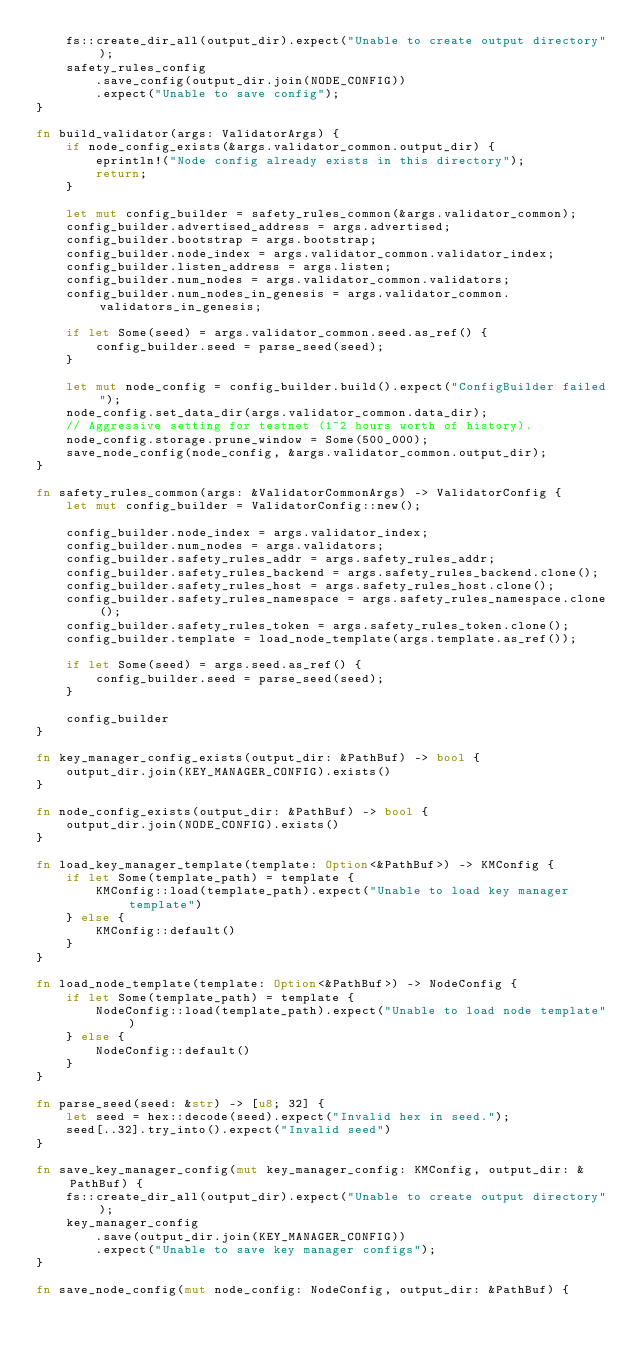Convert code to text. <code><loc_0><loc_0><loc_500><loc_500><_Rust_>    fs::create_dir_all(output_dir).expect("Unable to create output directory");
    safety_rules_config
        .save_config(output_dir.join(NODE_CONFIG))
        .expect("Unable to save config");
}

fn build_validator(args: ValidatorArgs) {
    if node_config_exists(&args.validator_common.output_dir) {
        eprintln!("Node config already exists in this directory");
        return;
    }

    let mut config_builder = safety_rules_common(&args.validator_common);
    config_builder.advertised_address = args.advertised;
    config_builder.bootstrap = args.bootstrap;
    config_builder.node_index = args.validator_common.validator_index;
    config_builder.listen_address = args.listen;
    config_builder.num_nodes = args.validator_common.validators;
    config_builder.num_nodes_in_genesis = args.validator_common.validators_in_genesis;

    if let Some(seed) = args.validator_common.seed.as_ref() {
        config_builder.seed = parse_seed(seed);
    }

    let mut node_config = config_builder.build().expect("ConfigBuilder failed");
    node_config.set_data_dir(args.validator_common.data_dir);
    // Aggressive setting for testnet (1~2 hours worth of history).
    node_config.storage.prune_window = Some(500_000);
    save_node_config(node_config, &args.validator_common.output_dir);
}

fn safety_rules_common(args: &ValidatorCommonArgs) -> ValidatorConfig {
    let mut config_builder = ValidatorConfig::new();

    config_builder.node_index = args.validator_index;
    config_builder.num_nodes = args.validators;
    config_builder.safety_rules_addr = args.safety_rules_addr;
    config_builder.safety_rules_backend = args.safety_rules_backend.clone();
    config_builder.safety_rules_host = args.safety_rules_host.clone();
    config_builder.safety_rules_namespace = args.safety_rules_namespace.clone();
    config_builder.safety_rules_token = args.safety_rules_token.clone();
    config_builder.template = load_node_template(args.template.as_ref());

    if let Some(seed) = args.seed.as_ref() {
        config_builder.seed = parse_seed(seed);
    }

    config_builder
}

fn key_manager_config_exists(output_dir: &PathBuf) -> bool {
    output_dir.join(KEY_MANAGER_CONFIG).exists()
}

fn node_config_exists(output_dir: &PathBuf) -> bool {
    output_dir.join(NODE_CONFIG).exists()
}

fn load_key_manager_template(template: Option<&PathBuf>) -> KMConfig {
    if let Some(template_path) = template {
        KMConfig::load(template_path).expect("Unable to load key manager template")
    } else {
        KMConfig::default()
    }
}

fn load_node_template(template: Option<&PathBuf>) -> NodeConfig {
    if let Some(template_path) = template {
        NodeConfig::load(template_path).expect("Unable to load node template")
    } else {
        NodeConfig::default()
    }
}

fn parse_seed(seed: &str) -> [u8; 32] {
    let seed = hex::decode(seed).expect("Invalid hex in seed.");
    seed[..32].try_into().expect("Invalid seed")
}

fn save_key_manager_config(mut key_manager_config: KMConfig, output_dir: &PathBuf) {
    fs::create_dir_all(output_dir).expect("Unable to create output directory");
    key_manager_config
        .save(output_dir.join(KEY_MANAGER_CONFIG))
        .expect("Unable to save key manager configs");
}

fn save_node_config(mut node_config: NodeConfig, output_dir: &PathBuf) {</code> 